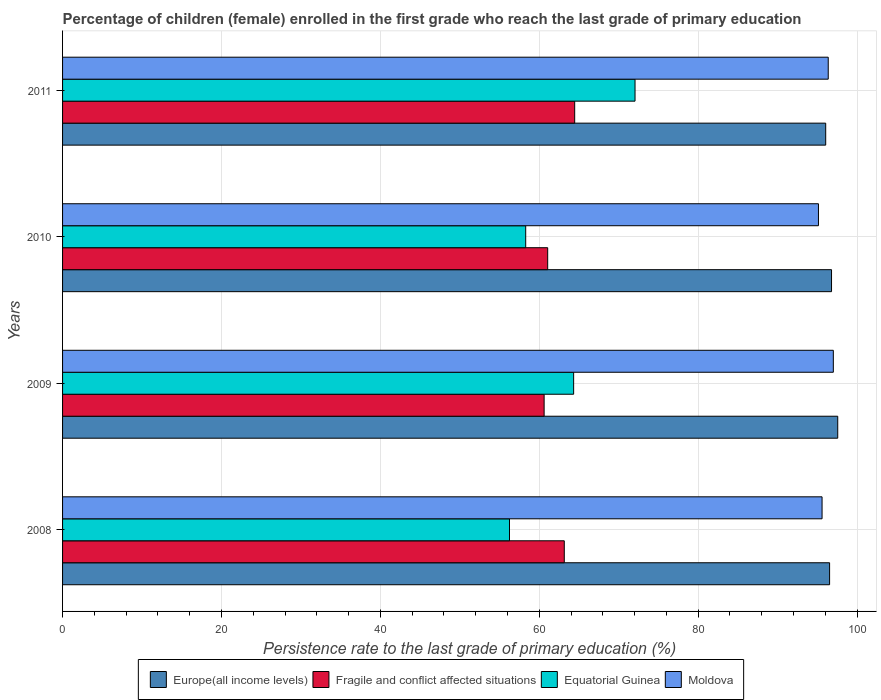Are the number of bars per tick equal to the number of legend labels?
Provide a short and direct response. Yes. Are the number of bars on each tick of the Y-axis equal?
Make the answer very short. Yes. How many bars are there on the 3rd tick from the top?
Ensure brevity in your answer.  4. How many bars are there on the 2nd tick from the bottom?
Ensure brevity in your answer.  4. In how many cases, is the number of bars for a given year not equal to the number of legend labels?
Offer a very short reply. 0. What is the persistence rate of children in Europe(all income levels) in 2008?
Your response must be concise. 96.55. Across all years, what is the maximum persistence rate of children in Fragile and conflict affected situations?
Offer a terse response. 64.46. Across all years, what is the minimum persistence rate of children in Europe(all income levels)?
Give a very brief answer. 96.06. In which year was the persistence rate of children in Moldova maximum?
Provide a succinct answer. 2009. What is the total persistence rate of children in Europe(all income levels) in the graph?
Give a very brief answer. 386.97. What is the difference between the persistence rate of children in Equatorial Guinea in 2008 and that in 2010?
Offer a terse response. -2.04. What is the difference between the persistence rate of children in Moldova in 2010 and the persistence rate of children in Fragile and conflict affected situations in 2008?
Give a very brief answer. 31.99. What is the average persistence rate of children in Equatorial Guinea per year?
Your answer should be compact. 62.73. In the year 2010, what is the difference between the persistence rate of children in Moldova and persistence rate of children in Europe(all income levels)?
Ensure brevity in your answer.  -1.65. In how many years, is the persistence rate of children in Fragile and conflict affected situations greater than 32 %?
Make the answer very short. 4. What is the ratio of the persistence rate of children in Moldova in 2009 to that in 2010?
Provide a short and direct response. 1.02. Is the persistence rate of children in Moldova in 2009 less than that in 2010?
Provide a succinct answer. No. Is the difference between the persistence rate of children in Moldova in 2009 and 2011 greater than the difference between the persistence rate of children in Europe(all income levels) in 2009 and 2011?
Make the answer very short. No. What is the difference between the highest and the second highest persistence rate of children in Fragile and conflict affected situations?
Your response must be concise. 1.31. What is the difference between the highest and the lowest persistence rate of children in Moldova?
Make the answer very short. 1.87. In how many years, is the persistence rate of children in Europe(all income levels) greater than the average persistence rate of children in Europe(all income levels) taken over all years?
Your answer should be compact. 2. Is it the case that in every year, the sum of the persistence rate of children in Europe(all income levels) and persistence rate of children in Moldova is greater than the sum of persistence rate of children in Fragile and conflict affected situations and persistence rate of children in Equatorial Guinea?
Make the answer very short. No. What does the 4th bar from the top in 2010 represents?
Make the answer very short. Europe(all income levels). What does the 4th bar from the bottom in 2010 represents?
Offer a terse response. Moldova. How many bars are there?
Provide a succinct answer. 16. How many years are there in the graph?
Your answer should be very brief. 4. Does the graph contain any zero values?
Ensure brevity in your answer.  No. How many legend labels are there?
Give a very brief answer. 4. What is the title of the graph?
Provide a short and direct response. Percentage of children (female) enrolled in the first grade who reach the last grade of primary education. Does "Burkina Faso" appear as one of the legend labels in the graph?
Provide a succinct answer. No. What is the label or title of the X-axis?
Your response must be concise. Persistence rate to the last grade of primary education (%). What is the label or title of the Y-axis?
Provide a succinct answer. Years. What is the Persistence rate to the last grade of primary education (%) in Europe(all income levels) in 2008?
Offer a very short reply. 96.55. What is the Persistence rate to the last grade of primary education (%) of Fragile and conflict affected situations in 2008?
Offer a terse response. 63.15. What is the Persistence rate to the last grade of primary education (%) of Equatorial Guinea in 2008?
Your answer should be compact. 56.26. What is the Persistence rate to the last grade of primary education (%) in Moldova in 2008?
Your response must be concise. 95.6. What is the Persistence rate to the last grade of primary education (%) in Europe(all income levels) in 2009?
Your response must be concise. 97.57. What is the Persistence rate to the last grade of primary education (%) of Fragile and conflict affected situations in 2009?
Keep it short and to the point. 60.62. What is the Persistence rate to the last grade of primary education (%) of Equatorial Guinea in 2009?
Offer a very short reply. 64.33. What is the Persistence rate to the last grade of primary education (%) of Moldova in 2009?
Your answer should be very brief. 97.02. What is the Persistence rate to the last grade of primary education (%) in Europe(all income levels) in 2010?
Provide a short and direct response. 96.79. What is the Persistence rate to the last grade of primary education (%) in Fragile and conflict affected situations in 2010?
Your answer should be very brief. 61.06. What is the Persistence rate to the last grade of primary education (%) in Equatorial Guinea in 2010?
Offer a terse response. 58.3. What is the Persistence rate to the last grade of primary education (%) of Moldova in 2010?
Your answer should be compact. 95.14. What is the Persistence rate to the last grade of primary education (%) of Europe(all income levels) in 2011?
Provide a short and direct response. 96.06. What is the Persistence rate to the last grade of primary education (%) in Fragile and conflict affected situations in 2011?
Keep it short and to the point. 64.46. What is the Persistence rate to the last grade of primary education (%) in Equatorial Guinea in 2011?
Provide a succinct answer. 72.06. What is the Persistence rate to the last grade of primary education (%) in Moldova in 2011?
Provide a succinct answer. 96.38. Across all years, what is the maximum Persistence rate to the last grade of primary education (%) in Europe(all income levels)?
Keep it short and to the point. 97.57. Across all years, what is the maximum Persistence rate to the last grade of primary education (%) of Fragile and conflict affected situations?
Ensure brevity in your answer.  64.46. Across all years, what is the maximum Persistence rate to the last grade of primary education (%) in Equatorial Guinea?
Keep it short and to the point. 72.06. Across all years, what is the maximum Persistence rate to the last grade of primary education (%) of Moldova?
Make the answer very short. 97.02. Across all years, what is the minimum Persistence rate to the last grade of primary education (%) in Europe(all income levels)?
Keep it short and to the point. 96.06. Across all years, what is the minimum Persistence rate to the last grade of primary education (%) in Fragile and conflict affected situations?
Ensure brevity in your answer.  60.62. Across all years, what is the minimum Persistence rate to the last grade of primary education (%) in Equatorial Guinea?
Give a very brief answer. 56.26. Across all years, what is the minimum Persistence rate to the last grade of primary education (%) of Moldova?
Offer a terse response. 95.14. What is the total Persistence rate to the last grade of primary education (%) in Europe(all income levels) in the graph?
Provide a short and direct response. 386.97. What is the total Persistence rate to the last grade of primary education (%) in Fragile and conflict affected situations in the graph?
Your response must be concise. 249.29. What is the total Persistence rate to the last grade of primary education (%) of Equatorial Guinea in the graph?
Your response must be concise. 250.94. What is the total Persistence rate to the last grade of primary education (%) of Moldova in the graph?
Keep it short and to the point. 384.14. What is the difference between the Persistence rate to the last grade of primary education (%) in Europe(all income levels) in 2008 and that in 2009?
Your response must be concise. -1.02. What is the difference between the Persistence rate to the last grade of primary education (%) in Fragile and conflict affected situations in 2008 and that in 2009?
Your answer should be very brief. 2.54. What is the difference between the Persistence rate to the last grade of primary education (%) in Equatorial Guinea in 2008 and that in 2009?
Your response must be concise. -8.07. What is the difference between the Persistence rate to the last grade of primary education (%) of Moldova in 2008 and that in 2009?
Offer a terse response. -1.42. What is the difference between the Persistence rate to the last grade of primary education (%) of Europe(all income levels) in 2008 and that in 2010?
Provide a succinct answer. -0.24. What is the difference between the Persistence rate to the last grade of primary education (%) of Fragile and conflict affected situations in 2008 and that in 2010?
Your response must be concise. 2.09. What is the difference between the Persistence rate to the last grade of primary education (%) of Equatorial Guinea in 2008 and that in 2010?
Provide a succinct answer. -2.04. What is the difference between the Persistence rate to the last grade of primary education (%) in Moldova in 2008 and that in 2010?
Your response must be concise. 0.45. What is the difference between the Persistence rate to the last grade of primary education (%) of Europe(all income levels) in 2008 and that in 2011?
Your answer should be very brief. 0.49. What is the difference between the Persistence rate to the last grade of primary education (%) of Fragile and conflict affected situations in 2008 and that in 2011?
Provide a short and direct response. -1.31. What is the difference between the Persistence rate to the last grade of primary education (%) of Equatorial Guinea in 2008 and that in 2011?
Your answer should be compact. -15.8. What is the difference between the Persistence rate to the last grade of primary education (%) in Moldova in 2008 and that in 2011?
Keep it short and to the point. -0.78. What is the difference between the Persistence rate to the last grade of primary education (%) of Europe(all income levels) in 2009 and that in 2010?
Ensure brevity in your answer.  0.78. What is the difference between the Persistence rate to the last grade of primary education (%) of Fragile and conflict affected situations in 2009 and that in 2010?
Make the answer very short. -0.45. What is the difference between the Persistence rate to the last grade of primary education (%) of Equatorial Guinea in 2009 and that in 2010?
Your answer should be compact. 6.03. What is the difference between the Persistence rate to the last grade of primary education (%) of Moldova in 2009 and that in 2010?
Provide a short and direct response. 1.87. What is the difference between the Persistence rate to the last grade of primary education (%) of Europe(all income levels) in 2009 and that in 2011?
Give a very brief answer. 1.51. What is the difference between the Persistence rate to the last grade of primary education (%) of Fragile and conflict affected situations in 2009 and that in 2011?
Keep it short and to the point. -3.85. What is the difference between the Persistence rate to the last grade of primary education (%) in Equatorial Guinea in 2009 and that in 2011?
Make the answer very short. -7.73. What is the difference between the Persistence rate to the last grade of primary education (%) in Moldova in 2009 and that in 2011?
Keep it short and to the point. 0.64. What is the difference between the Persistence rate to the last grade of primary education (%) in Europe(all income levels) in 2010 and that in 2011?
Ensure brevity in your answer.  0.73. What is the difference between the Persistence rate to the last grade of primary education (%) of Fragile and conflict affected situations in 2010 and that in 2011?
Your response must be concise. -3.4. What is the difference between the Persistence rate to the last grade of primary education (%) in Equatorial Guinea in 2010 and that in 2011?
Keep it short and to the point. -13.76. What is the difference between the Persistence rate to the last grade of primary education (%) in Moldova in 2010 and that in 2011?
Keep it short and to the point. -1.23. What is the difference between the Persistence rate to the last grade of primary education (%) of Europe(all income levels) in 2008 and the Persistence rate to the last grade of primary education (%) of Fragile and conflict affected situations in 2009?
Your response must be concise. 35.93. What is the difference between the Persistence rate to the last grade of primary education (%) of Europe(all income levels) in 2008 and the Persistence rate to the last grade of primary education (%) of Equatorial Guinea in 2009?
Your answer should be compact. 32.22. What is the difference between the Persistence rate to the last grade of primary education (%) in Europe(all income levels) in 2008 and the Persistence rate to the last grade of primary education (%) in Moldova in 2009?
Your answer should be very brief. -0.47. What is the difference between the Persistence rate to the last grade of primary education (%) in Fragile and conflict affected situations in 2008 and the Persistence rate to the last grade of primary education (%) in Equatorial Guinea in 2009?
Your answer should be compact. -1.18. What is the difference between the Persistence rate to the last grade of primary education (%) of Fragile and conflict affected situations in 2008 and the Persistence rate to the last grade of primary education (%) of Moldova in 2009?
Offer a terse response. -33.86. What is the difference between the Persistence rate to the last grade of primary education (%) in Equatorial Guinea in 2008 and the Persistence rate to the last grade of primary education (%) in Moldova in 2009?
Your answer should be compact. -40.76. What is the difference between the Persistence rate to the last grade of primary education (%) of Europe(all income levels) in 2008 and the Persistence rate to the last grade of primary education (%) of Fragile and conflict affected situations in 2010?
Make the answer very short. 35.48. What is the difference between the Persistence rate to the last grade of primary education (%) in Europe(all income levels) in 2008 and the Persistence rate to the last grade of primary education (%) in Equatorial Guinea in 2010?
Your response must be concise. 38.25. What is the difference between the Persistence rate to the last grade of primary education (%) in Europe(all income levels) in 2008 and the Persistence rate to the last grade of primary education (%) in Moldova in 2010?
Ensure brevity in your answer.  1.4. What is the difference between the Persistence rate to the last grade of primary education (%) of Fragile and conflict affected situations in 2008 and the Persistence rate to the last grade of primary education (%) of Equatorial Guinea in 2010?
Keep it short and to the point. 4.86. What is the difference between the Persistence rate to the last grade of primary education (%) of Fragile and conflict affected situations in 2008 and the Persistence rate to the last grade of primary education (%) of Moldova in 2010?
Offer a terse response. -31.99. What is the difference between the Persistence rate to the last grade of primary education (%) of Equatorial Guinea in 2008 and the Persistence rate to the last grade of primary education (%) of Moldova in 2010?
Give a very brief answer. -38.89. What is the difference between the Persistence rate to the last grade of primary education (%) of Europe(all income levels) in 2008 and the Persistence rate to the last grade of primary education (%) of Fragile and conflict affected situations in 2011?
Your answer should be very brief. 32.09. What is the difference between the Persistence rate to the last grade of primary education (%) of Europe(all income levels) in 2008 and the Persistence rate to the last grade of primary education (%) of Equatorial Guinea in 2011?
Provide a short and direct response. 24.49. What is the difference between the Persistence rate to the last grade of primary education (%) of Europe(all income levels) in 2008 and the Persistence rate to the last grade of primary education (%) of Moldova in 2011?
Provide a short and direct response. 0.17. What is the difference between the Persistence rate to the last grade of primary education (%) of Fragile and conflict affected situations in 2008 and the Persistence rate to the last grade of primary education (%) of Equatorial Guinea in 2011?
Your answer should be very brief. -8.9. What is the difference between the Persistence rate to the last grade of primary education (%) in Fragile and conflict affected situations in 2008 and the Persistence rate to the last grade of primary education (%) in Moldova in 2011?
Provide a succinct answer. -33.22. What is the difference between the Persistence rate to the last grade of primary education (%) in Equatorial Guinea in 2008 and the Persistence rate to the last grade of primary education (%) in Moldova in 2011?
Provide a short and direct response. -40.12. What is the difference between the Persistence rate to the last grade of primary education (%) of Europe(all income levels) in 2009 and the Persistence rate to the last grade of primary education (%) of Fragile and conflict affected situations in 2010?
Offer a terse response. 36.51. What is the difference between the Persistence rate to the last grade of primary education (%) in Europe(all income levels) in 2009 and the Persistence rate to the last grade of primary education (%) in Equatorial Guinea in 2010?
Your answer should be compact. 39.28. What is the difference between the Persistence rate to the last grade of primary education (%) of Europe(all income levels) in 2009 and the Persistence rate to the last grade of primary education (%) of Moldova in 2010?
Provide a succinct answer. 2.43. What is the difference between the Persistence rate to the last grade of primary education (%) of Fragile and conflict affected situations in 2009 and the Persistence rate to the last grade of primary education (%) of Equatorial Guinea in 2010?
Provide a short and direct response. 2.32. What is the difference between the Persistence rate to the last grade of primary education (%) in Fragile and conflict affected situations in 2009 and the Persistence rate to the last grade of primary education (%) in Moldova in 2010?
Your answer should be compact. -34.53. What is the difference between the Persistence rate to the last grade of primary education (%) of Equatorial Guinea in 2009 and the Persistence rate to the last grade of primary education (%) of Moldova in 2010?
Your answer should be compact. -30.82. What is the difference between the Persistence rate to the last grade of primary education (%) in Europe(all income levels) in 2009 and the Persistence rate to the last grade of primary education (%) in Fragile and conflict affected situations in 2011?
Provide a short and direct response. 33.11. What is the difference between the Persistence rate to the last grade of primary education (%) in Europe(all income levels) in 2009 and the Persistence rate to the last grade of primary education (%) in Equatorial Guinea in 2011?
Ensure brevity in your answer.  25.51. What is the difference between the Persistence rate to the last grade of primary education (%) in Europe(all income levels) in 2009 and the Persistence rate to the last grade of primary education (%) in Moldova in 2011?
Your response must be concise. 1.2. What is the difference between the Persistence rate to the last grade of primary education (%) of Fragile and conflict affected situations in 2009 and the Persistence rate to the last grade of primary education (%) of Equatorial Guinea in 2011?
Provide a succinct answer. -11.44. What is the difference between the Persistence rate to the last grade of primary education (%) of Fragile and conflict affected situations in 2009 and the Persistence rate to the last grade of primary education (%) of Moldova in 2011?
Provide a short and direct response. -35.76. What is the difference between the Persistence rate to the last grade of primary education (%) of Equatorial Guinea in 2009 and the Persistence rate to the last grade of primary education (%) of Moldova in 2011?
Your response must be concise. -32.05. What is the difference between the Persistence rate to the last grade of primary education (%) in Europe(all income levels) in 2010 and the Persistence rate to the last grade of primary education (%) in Fragile and conflict affected situations in 2011?
Give a very brief answer. 32.33. What is the difference between the Persistence rate to the last grade of primary education (%) of Europe(all income levels) in 2010 and the Persistence rate to the last grade of primary education (%) of Equatorial Guinea in 2011?
Keep it short and to the point. 24.73. What is the difference between the Persistence rate to the last grade of primary education (%) in Europe(all income levels) in 2010 and the Persistence rate to the last grade of primary education (%) in Moldova in 2011?
Your answer should be very brief. 0.42. What is the difference between the Persistence rate to the last grade of primary education (%) in Fragile and conflict affected situations in 2010 and the Persistence rate to the last grade of primary education (%) in Equatorial Guinea in 2011?
Your answer should be very brief. -10.99. What is the difference between the Persistence rate to the last grade of primary education (%) of Fragile and conflict affected situations in 2010 and the Persistence rate to the last grade of primary education (%) of Moldova in 2011?
Ensure brevity in your answer.  -35.31. What is the difference between the Persistence rate to the last grade of primary education (%) in Equatorial Guinea in 2010 and the Persistence rate to the last grade of primary education (%) in Moldova in 2011?
Offer a terse response. -38.08. What is the average Persistence rate to the last grade of primary education (%) in Europe(all income levels) per year?
Offer a very short reply. 96.74. What is the average Persistence rate to the last grade of primary education (%) of Fragile and conflict affected situations per year?
Give a very brief answer. 62.32. What is the average Persistence rate to the last grade of primary education (%) in Equatorial Guinea per year?
Offer a very short reply. 62.73. What is the average Persistence rate to the last grade of primary education (%) in Moldova per year?
Your answer should be very brief. 96.03. In the year 2008, what is the difference between the Persistence rate to the last grade of primary education (%) in Europe(all income levels) and Persistence rate to the last grade of primary education (%) in Fragile and conflict affected situations?
Keep it short and to the point. 33.39. In the year 2008, what is the difference between the Persistence rate to the last grade of primary education (%) in Europe(all income levels) and Persistence rate to the last grade of primary education (%) in Equatorial Guinea?
Your response must be concise. 40.29. In the year 2008, what is the difference between the Persistence rate to the last grade of primary education (%) of Europe(all income levels) and Persistence rate to the last grade of primary education (%) of Moldova?
Your response must be concise. 0.95. In the year 2008, what is the difference between the Persistence rate to the last grade of primary education (%) of Fragile and conflict affected situations and Persistence rate to the last grade of primary education (%) of Equatorial Guinea?
Your answer should be very brief. 6.9. In the year 2008, what is the difference between the Persistence rate to the last grade of primary education (%) in Fragile and conflict affected situations and Persistence rate to the last grade of primary education (%) in Moldova?
Offer a terse response. -32.45. In the year 2008, what is the difference between the Persistence rate to the last grade of primary education (%) in Equatorial Guinea and Persistence rate to the last grade of primary education (%) in Moldova?
Offer a very short reply. -39.34. In the year 2009, what is the difference between the Persistence rate to the last grade of primary education (%) of Europe(all income levels) and Persistence rate to the last grade of primary education (%) of Fragile and conflict affected situations?
Ensure brevity in your answer.  36.96. In the year 2009, what is the difference between the Persistence rate to the last grade of primary education (%) of Europe(all income levels) and Persistence rate to the last grade of primary education (%) of Equatorial Guinea?
Your response must be concise. 33.24. In the year 2009, what is the difference between the Persistence rate to the last grade of primary education (%) of Europe(all income levels) and Persistence rate to the last grade of primary education (%) of Moldova?
Provide a short and direct response. 0.55. In the year 2009, what is the difference between the Persistence rate to the last grade of primary education (%) in Fragile and conflict affected situations and Persistence rate to the last grade of primary education (%) in Equatorial Guinea?
Give a very brief answer. -3.71. In the year 2009, what is the difference between the Persistence rate to the last grade of primary education (%) of Fragile and conflict affected situations and Persistence rate to the last grade of primary education (%) of Moldova?
Your answer should be compact. -36.4. In the year 2009, what is the difference between the Persistence rate to the last grade of primary education (%) in Equatorial Guinea and Persistence rate to the last grade of primary education (%) in Moldova?
Make the answer very short. -32.69. In the year 2010, what is the difference between the Persistence rate to the last grade of primary education (%) of Europe(all income levels) and Persistence rate to the last grade of primary education (%) of Fragile and conflict affected situations?
Your response must be concise. 35.73. In the year 2010, what is the difference between the Persistence rate to the last grade of primary education (%) of Europe(all income levels) and Persistence rate to the last grade of primary education (%) of Equatorial Guinea?
Give a very brief answer. 38.5. In the year 2010, what is the difference between the Persistence rate to the last grade of primary education (%) in Europe(all income levels) and Persistence rate to the last grade of primary education (%) in Moldova?
Keep it short and to the point. 1.65. In the year 2010, what is the difference between the Persistence rate to the last grade of primary education (%) in Fragile and conflict affected situations and Persistence rate to the last grade of primary education (%) in Equatorial Guinea?
Keep it short and to the point. 2.77. In the year 2010, what is the difference between the Persistence rate to the last grade of primary education (%) in Fragile and conflict affected situations and Persistence rate to the last grade of primary education (%) in Moldova?
Give a very brief answer. -34.08. In the year 2010, what is the difference between the Persistence rate to the last grade of primary education (%) in Equatorial Guinea and Persistence rate to the last grade of primary education (%) in Moldova?
Provide a succinct answer. -36.85. In the year 2011, what is the difference between the Persistence rate to the last grade of primary education (%) of Europe(all income levels) and Persistence rate to the last grade of primary education (%) of Fragile and conflict affected situations?
Give a very brief answer. 31.6. In the year 2011, what is the difference between the Persistence rate to the last grade of primary education (%) of Europe(all income levels) and Persistence rate to the last grade of primary education (%) of Equatorial Guinea?
Offer a very short reply. 24. In the year 2011, what is the difference between the Persistence rate to the last grade of primary education (%) in Europe(all income levels) and Persistence rate to the last grade of primary education (%) in Moldova?
Your answer should be very brief. -0.32. In the year 2011, what is the difference between the Persistence rate to the last grade of primary education (%) of Fragile and conflict affected situations and Persistence rate to the last grade of primary education (%) of Equatorial Guinea?
Keep it short and to the point. -7.6. In the year 2011, what is the difference between the Persistence rate to the last grade of primary education (%) of Fragile and conflict affected situations and Persistence rate to the last grade of primary education (%) of Moldova?
Make the answer very short. -31.91. In the year 2011, what is the difference between the Persistence rate to the last grade of primary education (%) in Equatorial Guinea and Persistence rate to the last grade of primary education (%) in Moldova?
Offer a terse response. -24.32. What is the ratio of the Persistence rate to the last grade of primary education (%) of Europe(all income levels) in 2008 to that in 2009?
Keep it short and to the point. 0.99. What is the ratio of the Persistence rate to the last grade of primary education (%) of Fragile and conflict affected situations in 2008 to that in 2009?
Your response must be concise. 1.04. What is the ratio of the Persistence rate to the last grade of primary education (%) in Equatorial Guinea in 2008 to that in 2009?
Your answer should be compact. 0.87. What is the ratio of the Persistence rate to the last grade of primary education (%) of Moldova in 2008 to that in 2009?
Give a very brief answer. 0.99. What is the ratio of the Persistence rate to the last grade of primary education (%) in Europe(all income levels) in 2008 to that in 2010?
Keep it short and to the point. 1. What is the ratio of the Persistence rate to the last grade of primary education (%) of Fragile and conflict affected situations in 2008 to that in 2010?
Your answer should be very brief. 1.03. What is the ratio of the Persistence rate to the last grade of primary education (%) in Moldova in 2008 to that in 2010?
Your answer should be compact. 1. What is the ratio of the Persistence rate to the last grade of primary education (%) in Fragile and conflict affected situations in 2008 to that in 2011?
Provide a succinct answer. 0.98. What is the ratio of the Persistence rate to the last grade of primary education (%) in Equatorial Guinea in 2008 to that in 2011?
Ensure brevity in your answer.  0.78. What is the ratio of the Persistence rate to the last grade of primary education (%) of Europe(all income levels) in 2009 to that in 2010?
Provide a succinct answer. 1.01. What is the ratio of the Persistence rate to the last grade of primary education (%) in Fragile and conflict affected situations in 2009 to that in 2010?
Provide a succinct answer. 0.99. What is the ratio of the Persistence rate to the last grade of primary education (%) in Equatorial Guinea in 2009 to that in 2010?
Provide a succinct answer. 1.1. What is the ratio of the Persistence rate to the last grade of primary education (%) of Moldova in 2009 to that in 2010?
Your answer should be very brief. 1.02. What is the ratio of the Persistence rate to the last grade of primary education (%) of Europe(all income levels) in 2009 to that in 2011?
Ensure brevity in your answer.  1.02. What is the ratio of the Persistence rate to the last grade of primary education (%) of Fragile and conflict affected situations in 2009 to that in 2011?
Offer a terse response. 0.94. What is the ratio of the Persistence rate to the last grade of primary education (%) in Equatorial Guinea in 2009 to that in 2011?
Give a very brief answer. 0.89. What is the ratio of the Persistence rate to the last grade of primary education (%) in Europe(all income levels) in 2010 to that in 2011?
Provide a short and direct response. 1.01. What is the ratio of the Persistence rate to the last grade of primary education (%) of Fragile and conflict affected situations in 2010 to that in 2011?
Offer a terse response. 0.95. What is the ratio of the Persistence rate to the last grade of primary education (%) of Equatorial Guinea in 2010 to that in 2011?
Offer a terse response. 0.81. What is the ratio of the Persistence rate to the last grade of primary education (%) in Moldova in 2010 to that in 2011?
Your response must be concise. 0.99. What is the difference between the highest and the second highest Persistence rate to the last grade of primary education (%) of Europe(all income levels)?
Provide a short and direct response. 0.78. What is the difference between the highest and the second highest Persistence rate to the last grade of primary education (%) in Fragile and conflict affected situations?
Make the answer very short. 1.31. What is the difference between the highest and the second highest Persistence rate to the last grade of primary education (%) of Equatorial Guinea?
Give a very brief answer. 7.73. What is the difference between the highest and the second highest Persistence rate to the last grade of primary education (%) in Moldova?
Give a very brief answer. 0.64. What is the difference between the highest and the lowest Persistence rate to the last grade of primary education (%) of Europe(all income levels)?
Offer a terse response. 1.51. What is the difference between the highest and the lowest Persistence rate to the last grade of primary education (%) of Fragile and conflict affected situations?
Offer a very short reply. 3.85. What is the difference between the highest and the lowest Persistence rate to the last grade of primary education (%) in Equatorial Guinea?
Provide a short and direct response. 15.8. What is the difference between the highest and the lowest Persistence rate to the last grade of primary education (%) of Moldova?
Provide a succinct answer. 1.87. 